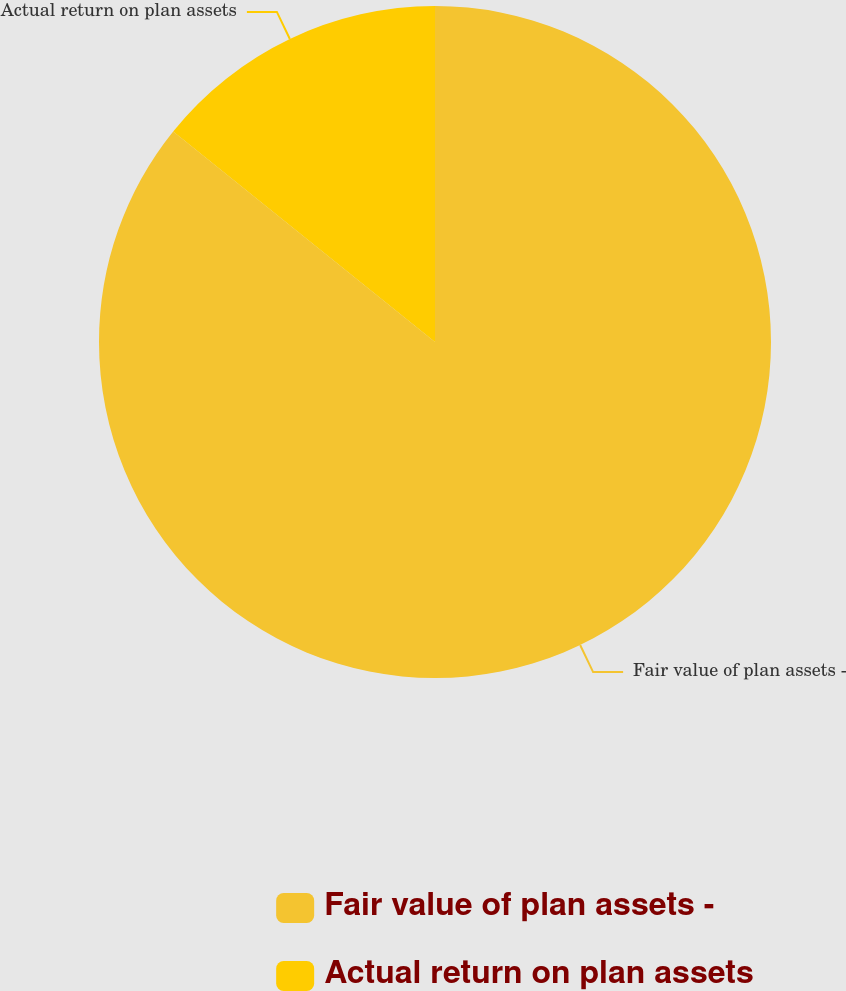<chart> <loc_0><loc_0><loc_500><loc_500><pie_chart><fcel>Fair value of plan assets -<fcel>Actual return on plan assets<nl><fcel>85.78%<fcel>14.22%<nl></chart> 